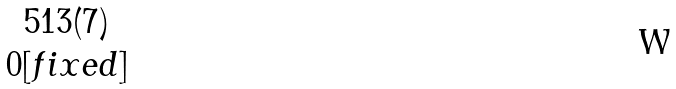<formula> <loc_0><loc_0><loc_500><loc_500>\begin{matrix} 5 1 3 ( 7 ) \\ 0 [ f i x e d ] \end{matrix}</formula> 